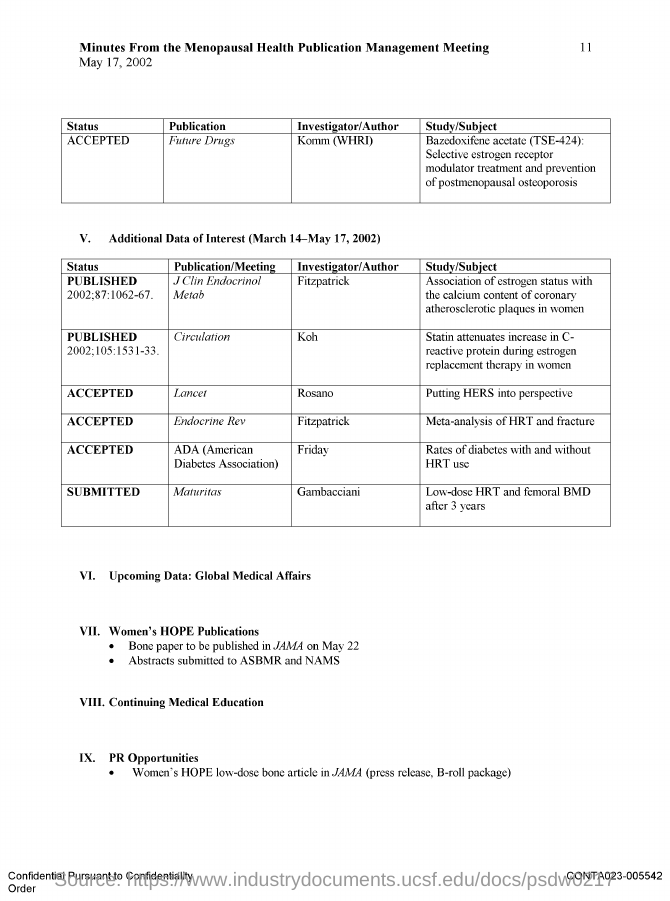Who is the investigator/author for the study titled 'Putting HERS into perspective'?
Your answer should be very brief. Rosano. Who is the investigator/author for study titled 'Meta-analysis of HRT and fracture'?
Ensure brevity in your answer.  Fitzpatrick. What is the date of Minutes from the Menopausal Health Publication Management Meeting?
Offer a very short reply. May 17, 2002. What is the status of the publication 'Future Drugs'?
Give a very brief answer. ACCEPTED. 